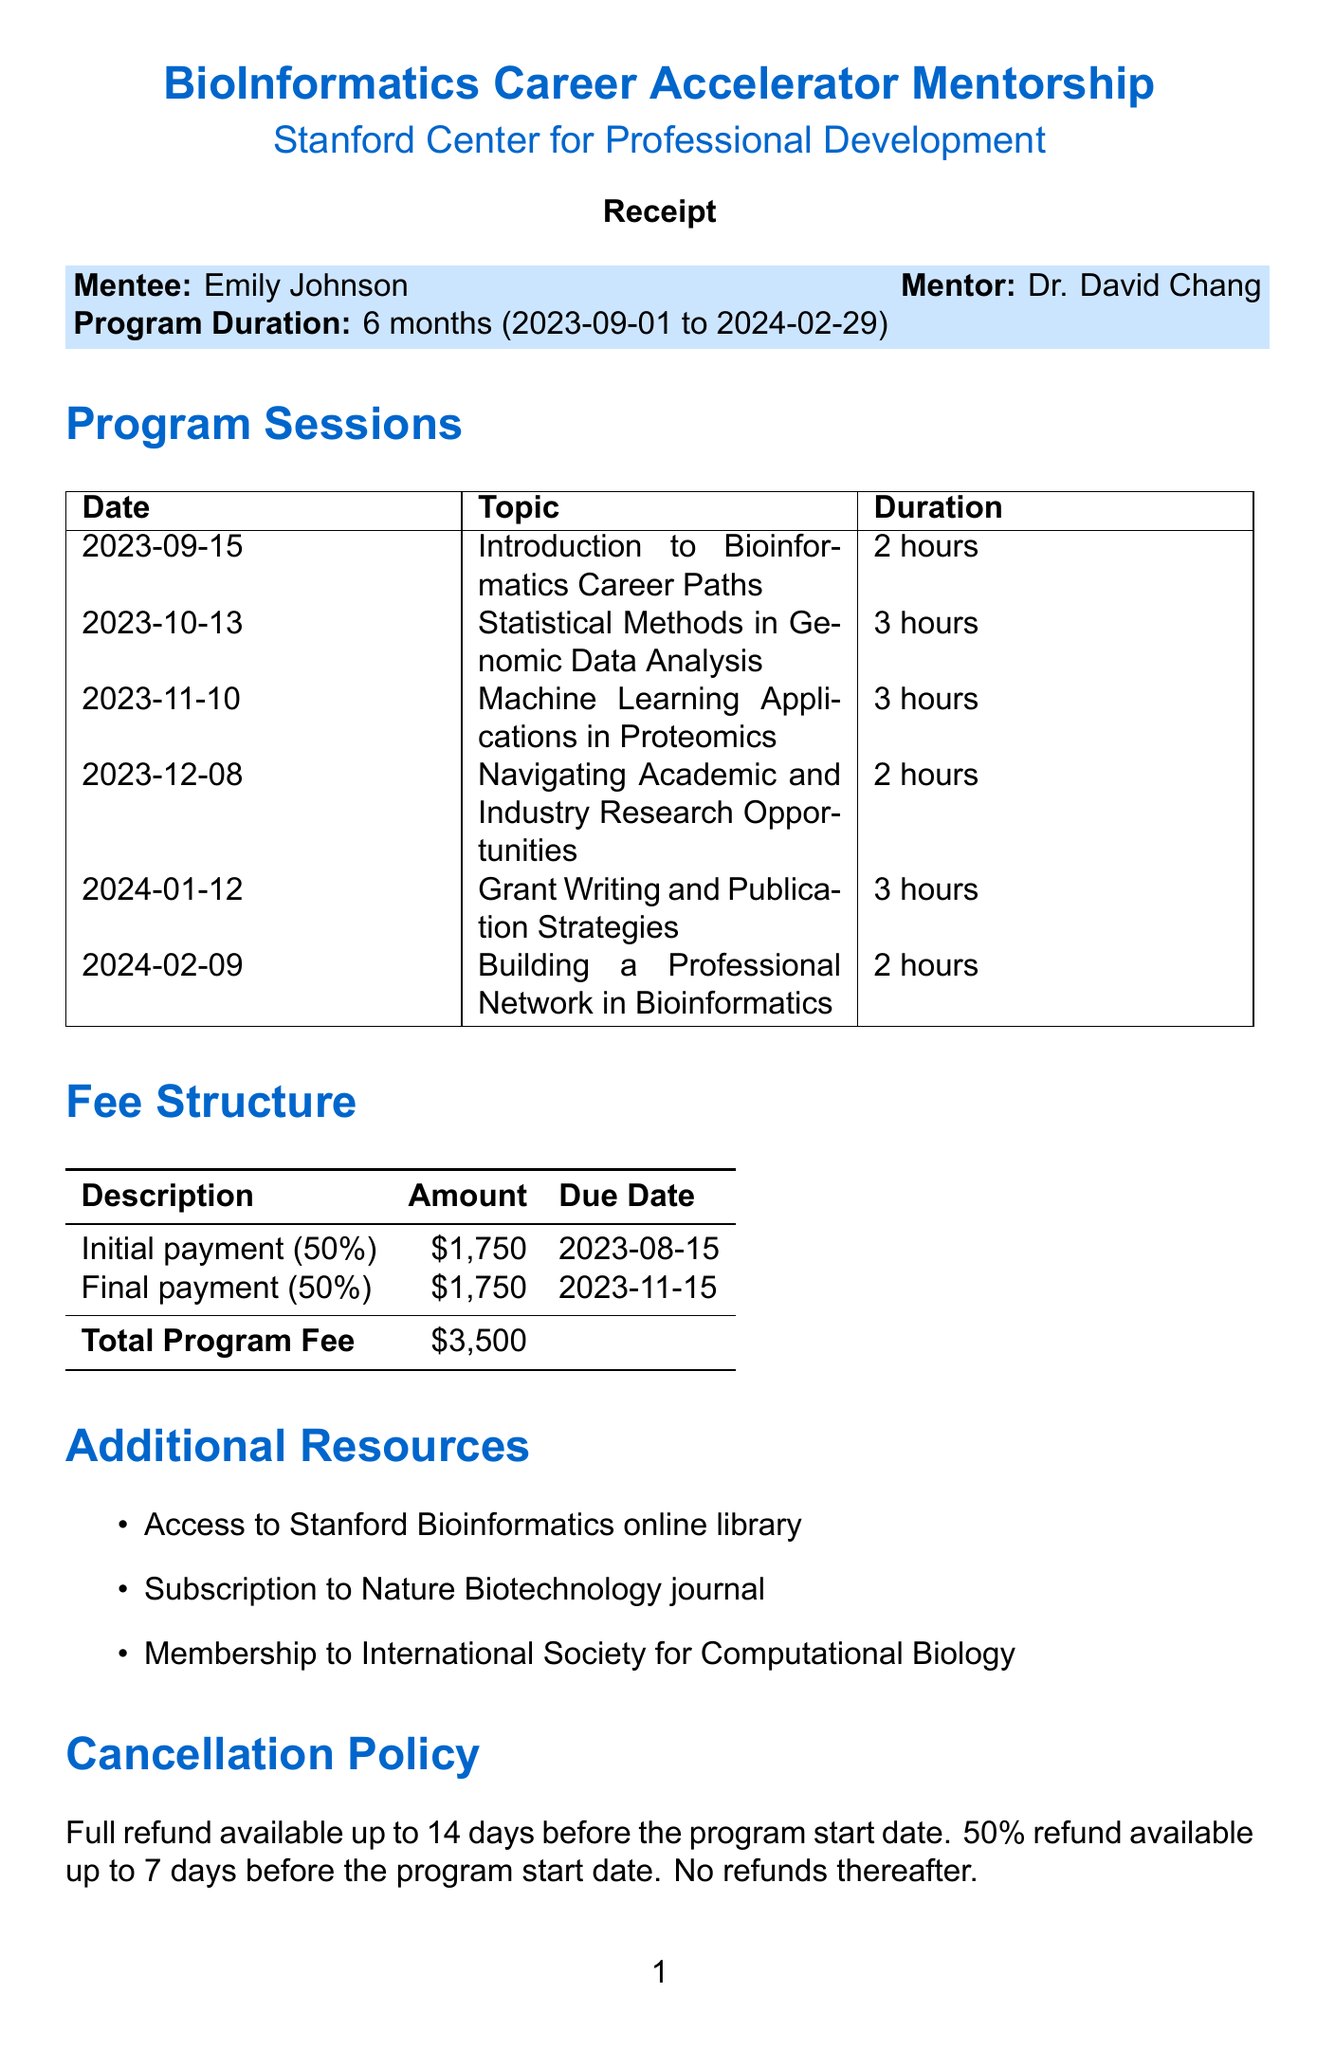What is the name of the program? The program is specifically named in the document.
Answer: BioInformatics Career Accelerator Mentorship Who is the mentor for the program? The mentor's name is clearly stated in the document.
Answer: Dr. David Chang What is the total program fee? The total fee is outlined in the fee structure section of the document.
Answer: $3500 When is the first session date? The date of the first session is listed chronologically in the sessions section.
Answer: 2023-09-15 How long is each session on average? By calculating the average duration from the sessions listed in the document, we arrive at the average session duration.
Answer: 2.5 hours What is the cancellation policy for refunds? The cancellation policy is explicitly detailed in the document.
Answer: Full refund available up to 14 days before the program start date When is the final payment due? The due date for the final payment is specified in the payment schedule of the document.
Answer: 2023-11-15 What additional resource includes a journal subscription? The additional resources section lists specific resources including a journal subscription.
Answer: Subscription to Nature Biotechnology journal How many sessions will be held during the program? The total number of sessions listed in the document gives this information.
Answer: 6 sessions 